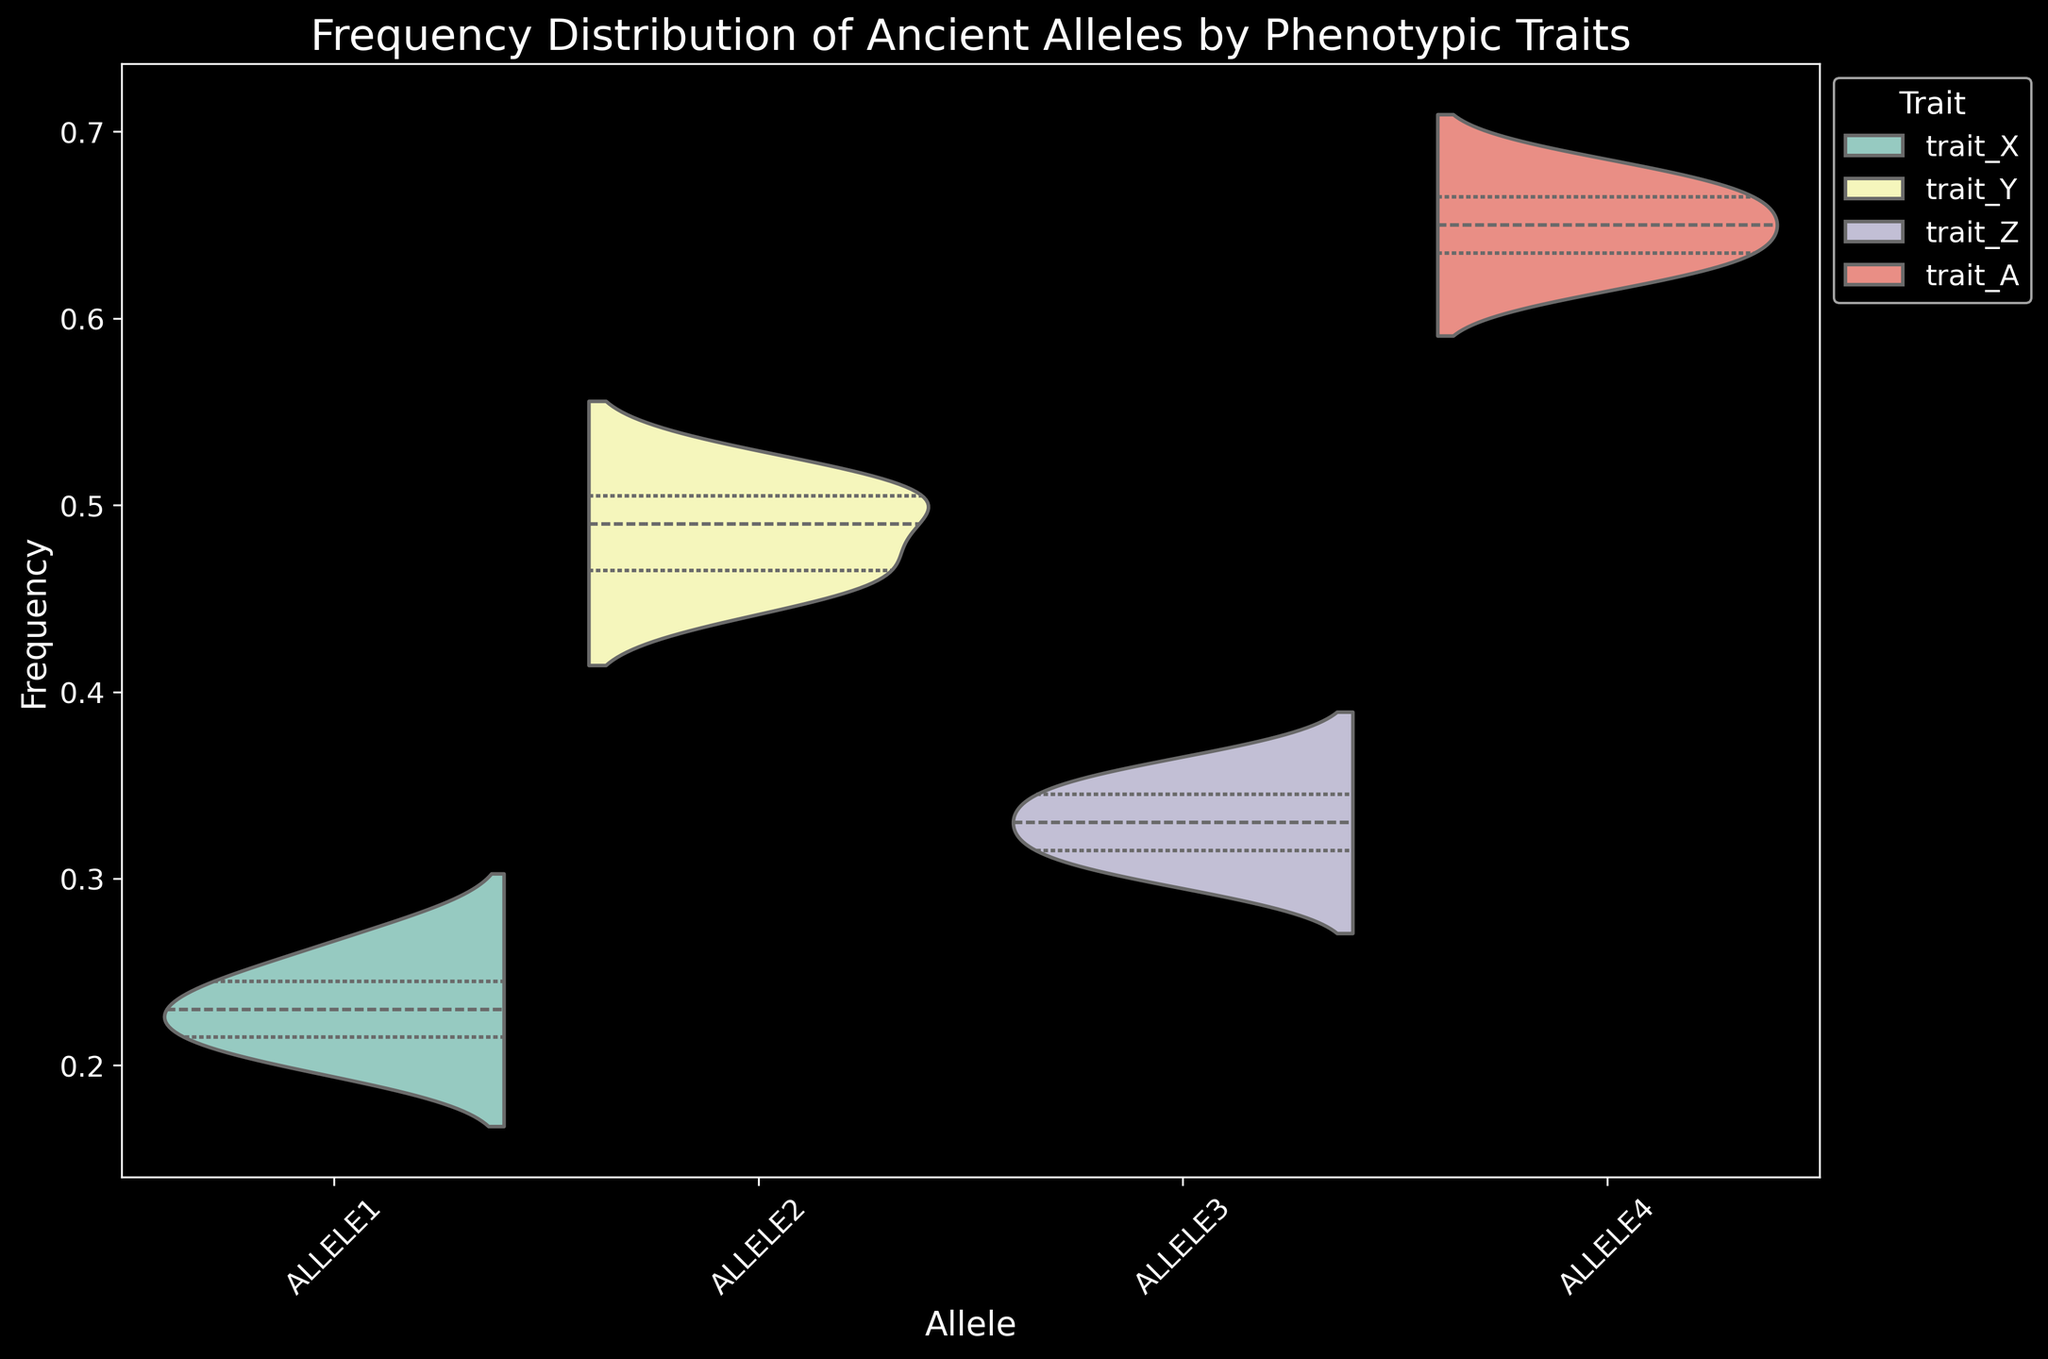What is the median frequency of ALLELE1 in the plot? To find the median frequency of ALLELE1, observe the central value of the distribution for ALLELE1 when split by "trait_X." In a violin plot, the inner quartile lines help identify this. From the visual, it appears around the 0.23 mark.
Answer: 0.23 Which allele shows the highest frequency value and what is it? By inspecting the plot, identify the peak of each distribution. ALLELE4 associated with "trait_A" reaches the highest frequency, as seen on the y-axis.
Answer: ALLELE4 with frequency 0.68 How does the variance in frequency compare between ALLELE2 and ALLELE3? Compare the spread and shape of the distributions. ALLELE2 has a broader distribution between 0.45 to 0.52, indicating higher variance, whereas ALLELE3 is more compact between 0.30 to 0.36.
Answer: ALLELE2 has higher variance What is the range of frequencies for ALLELE4? Identify the minimum and maximum points of the distribution for ALLELE4. The lowest value is 0.62, and the highest is 0.68. Thus, the range is 0.68-0.62.
Answer: 0.06 Among all alleles, which one has the smallest median frequency? Observe the inner quartile ranges of each allele's distribution. ALLELE1 has the lowest central value, which is around 0.23.
Answer: ALLELE1 Between ALLELE2 and ALLELE4, which has a wider interquartile range (IQR)? The IQR is the box width within the violins. ALLELE2's IQR spans from about 0.46 to 0.51, making it wider than ALLELE4, which spans approximately from 0.63 to 0.67.
Answer: ALLELE2 What is the skewness of the frequency distribution for ALLELE3? Visualize the plot for ALLELE3: it shows a longer tail on the lower side (towards 0.30), suggesting negative skewness.
Answer: Negatively skewed 